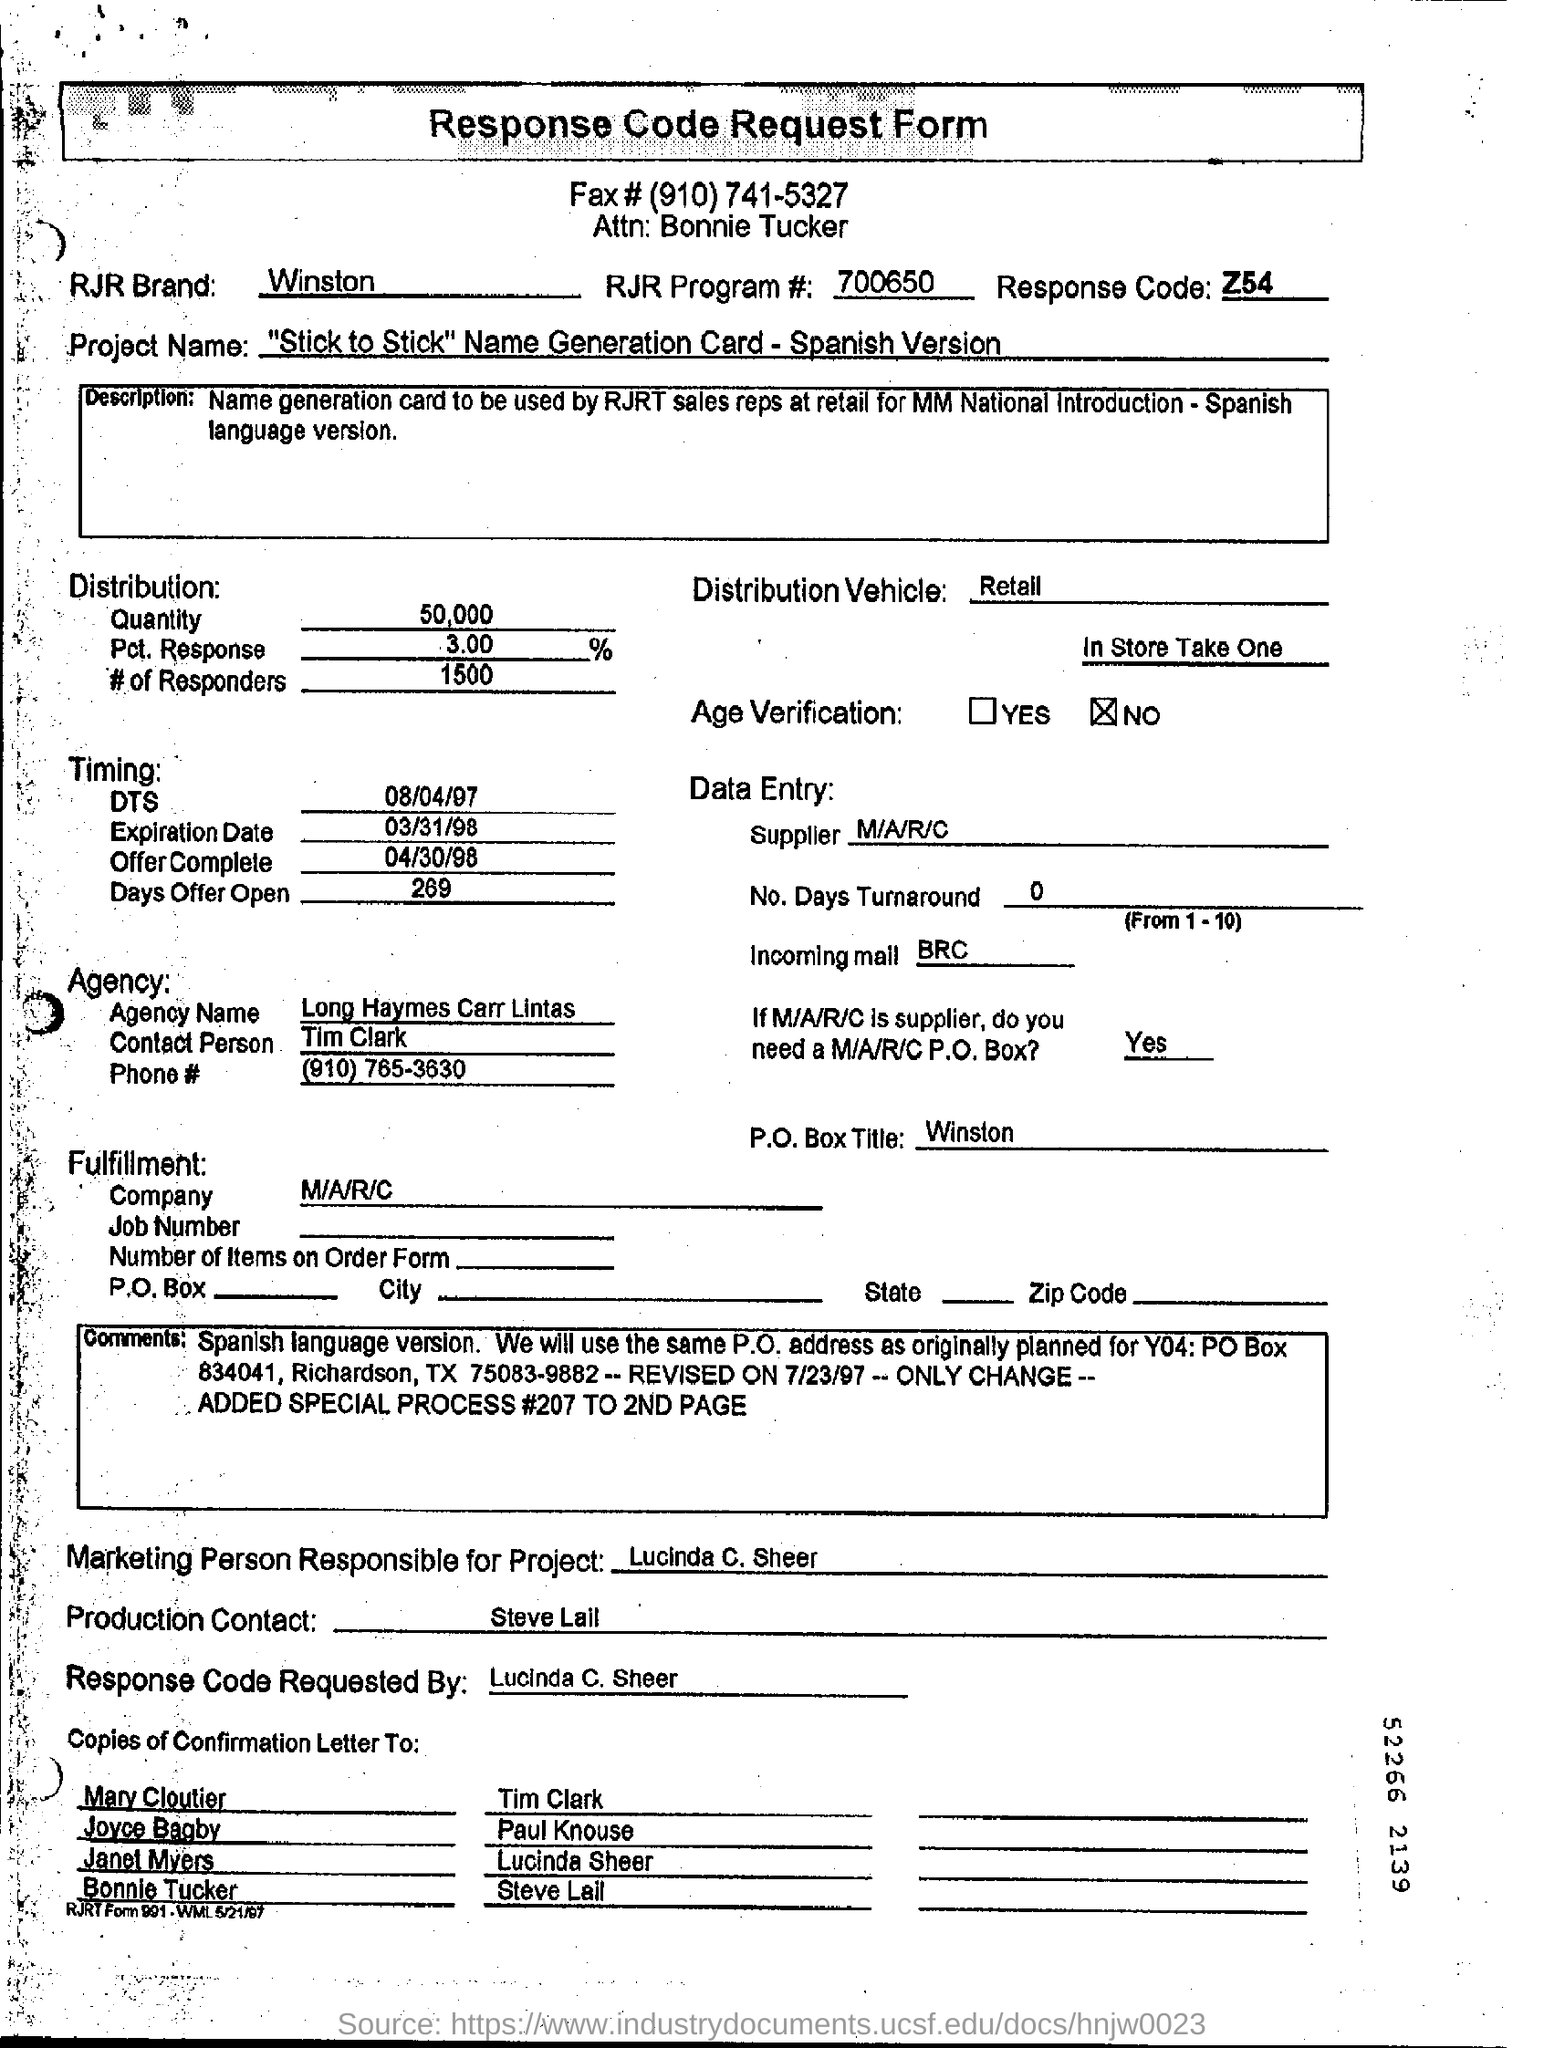What is the name of rjr brand?
Provide a short and direct response. Winston. What is the response code?
Your answer should be very brief. Z54. Who is the contact person?
Give a very brief answer. Tim Clark. Who is the supplier?
Provide a succinct answer. M/A/R/C. Response code requested by whom?
Provide a succinct answer. Lucinda C. Sheer. Is there any age verification?
Your response must be concise. No. 